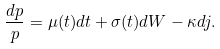<formula> <loc_0><loc_0><loc_500><loc_500>\frac { d p } { p } = \mu ( t ) d t + \sigma ( t ) d W - \kappa d j .</formula> 